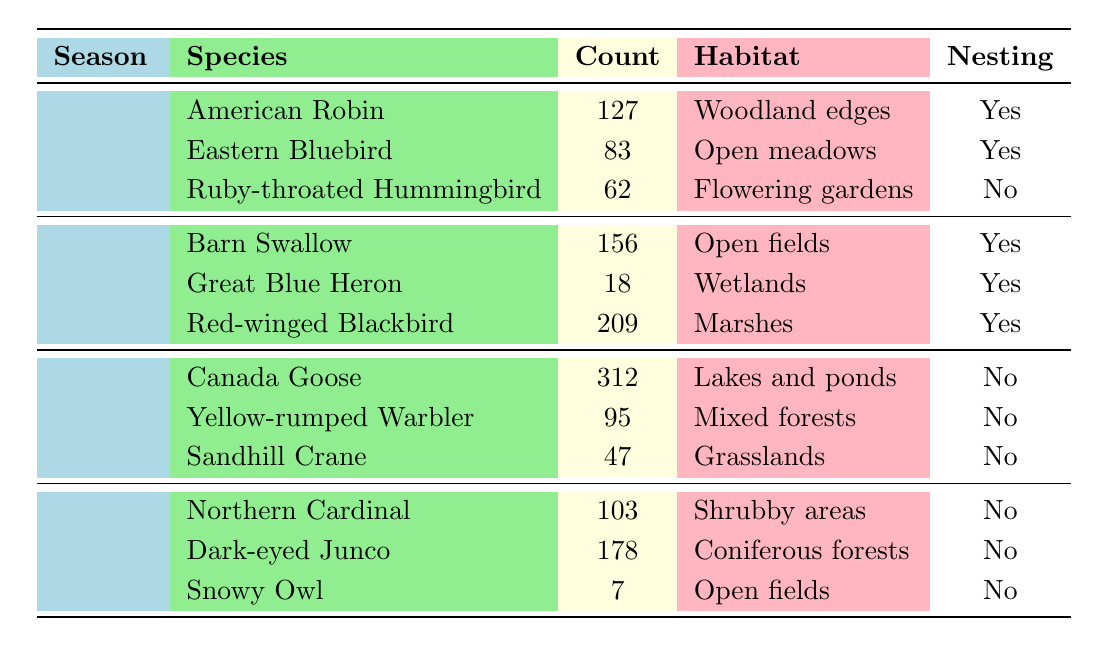What is the most sighted bird species during the Summer season? Looking at the Summer entries, the species with the highest count is the Red-winged Blackbird, with a count of 209.
Answer: Red-winged Blackbird How many bird species were sighted in the Fall? The Fall season has three species listed: Canada Goose, Yellow-rumped Warbler, and Sandhill Crane.
Answer: 3 Which species has the lowest count in the Winter season? In Winter, the Snowy Owl has the lowest count at 7.
Answer: Snowy Owl What is the total count of bird species sightings in Spring? Summing up the counts for Spring: 127 (American Robin) + 83 (Eastern Bluebird) + 62 (Ruby-throated Hummingbird) = 272.
Answer: 272 Are there any bird species that nest in the Winter? Looking at the Winter season data, all listed species (Northern Cardinal, Dark-eyed Junco, Snowy Owl) do not nest, as indicated by 'No' in the Nesting column.
Answer: No Which season had the highest overall bird count and what was that count? Calculating the counts for each season: Spring (272), Summer (383), Fall (454), Winter (288). The highest count is in Fall with 454.
Answer: Fall, 454 Is the Eastern Bluebird nesting in the Sanctuary during Spring? Yes, the Eastern Bluebird’s nesting status in Spring is marked as 'Yes' in the table.
Answer: Yes How many bird species are classified as nesting in the Summer season? In Summer, there are three species: Barn Swallow, Great Blue Heron, and Red-winged Blackbird, all marked as nesting (Yes).
Answer: 3 What is the habitat of the American Robin? The American Robin is found in woodland edges, as shown in the table under its habitat column.
Answer: Woodland edges How does the count of Canada Goose sightings compare to that of the Ruby-throated Hummingbird? The count of Canada Goose sightings is 312, while Ruby-throated Hummingbird has 62. Therefore, Canada Goose sightings are higher by 250.
Answer: Canada Goose is 250 higher 